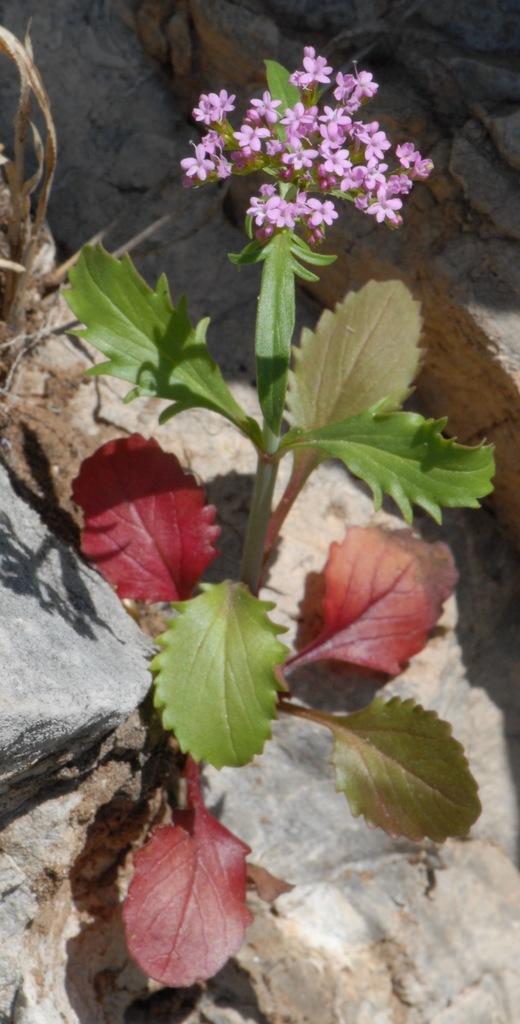Could you give a brief overview of what you see in this image? In the center of the image there is a flower plant. At the bottom of the image there are stones. 